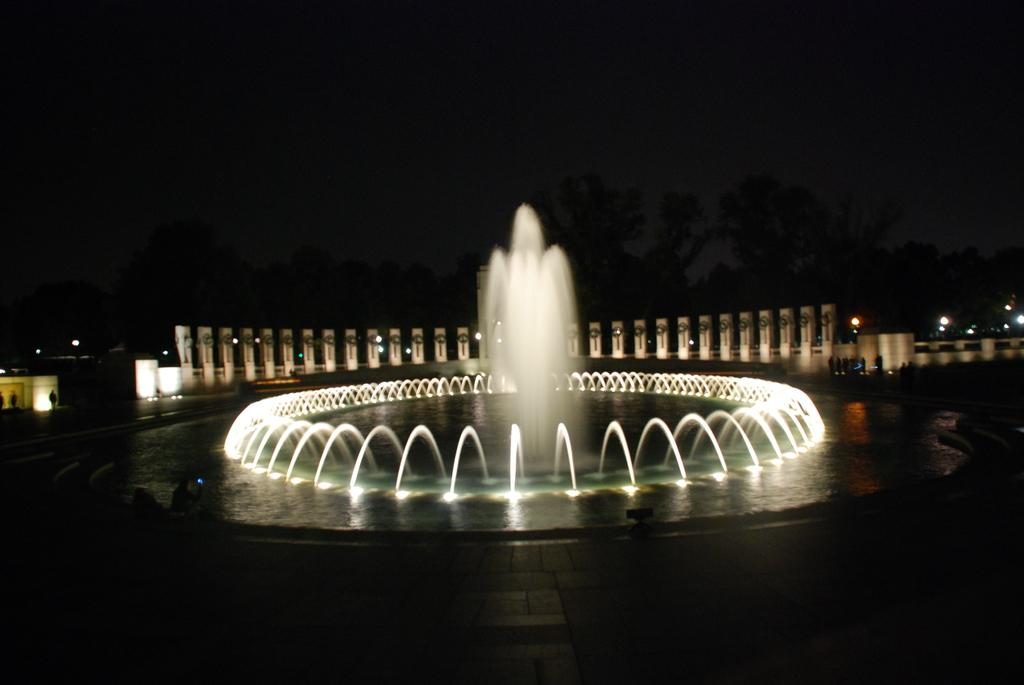What can be seen in the image that involves water? There are fountains with pipes in the image. What architectural features are visible in the background of the image? There are pillars in the background of the image. What type of vegetation is present in the background of the image? There are trees in the background of the image. What part of the natural environment is visible in the image? The sky is visible in the background of the image. How would you describe the lighting in the image? The background appears to be dark. Can you see a can of soda in the image? There is no can of soda present in the image. Is there a minister giving a speech in the image? There is no minister or speech present in the image. 